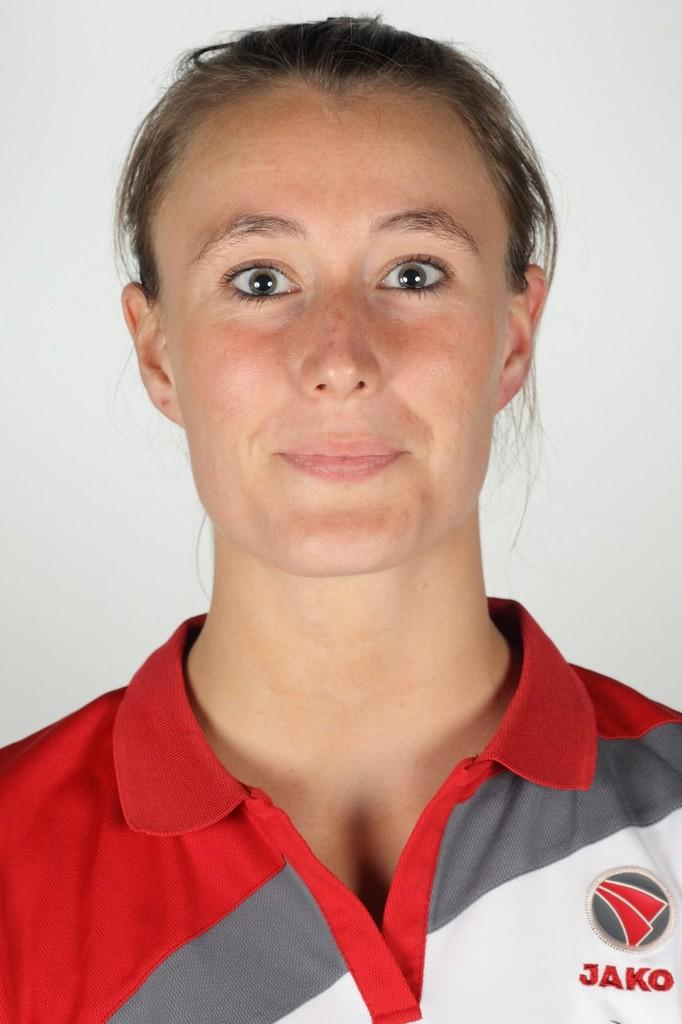<image>
Present a compact description of the photo's key features. A woman in a red and white and gray shirt that says Jako on it. 